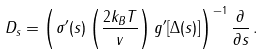<formula> <loc_0><loc_0><loc_500><loc_500>D _ { s } = \left ( \sigma ^ { \prime } ( s ) \left ( \frac { 2 k _ { B } T } { v } \right ) g ^ { \prime } [ \Delta ( s ) ] \right ) ^ { - 1 } \frac { \partial } { \partial s } \, .</formula> 